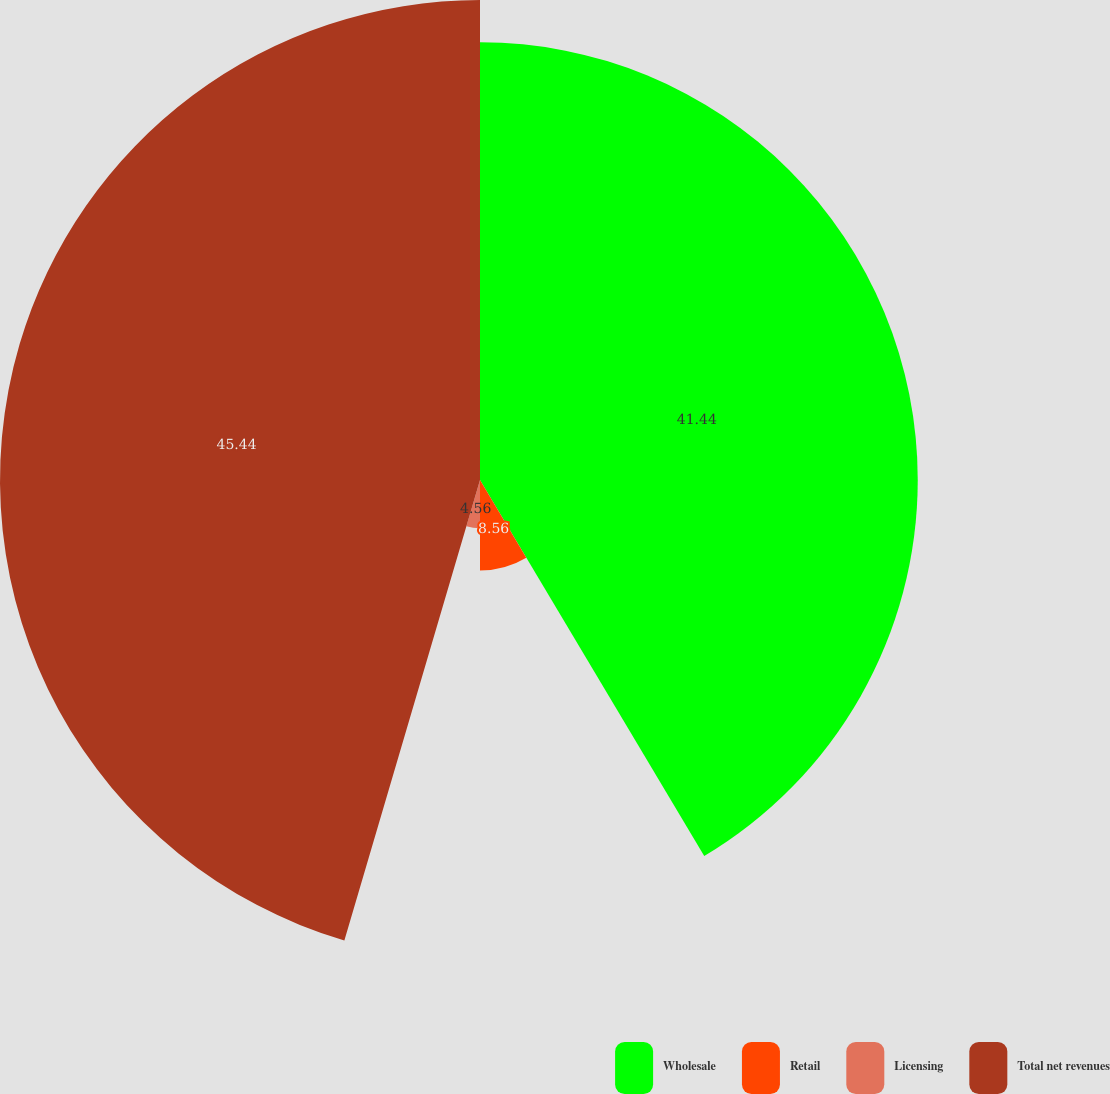Convert chart. <chart><loc_0><loc_0><loc_500><loc_500><pie_chart><fcel>Wholesale<fcel>Retail<fcel>Licensing<fcel>Total net revenues<nl><fcel>41.44%<fcel>8.56%<fcel>4.56%<fcel>45.44%<nl></chart> 